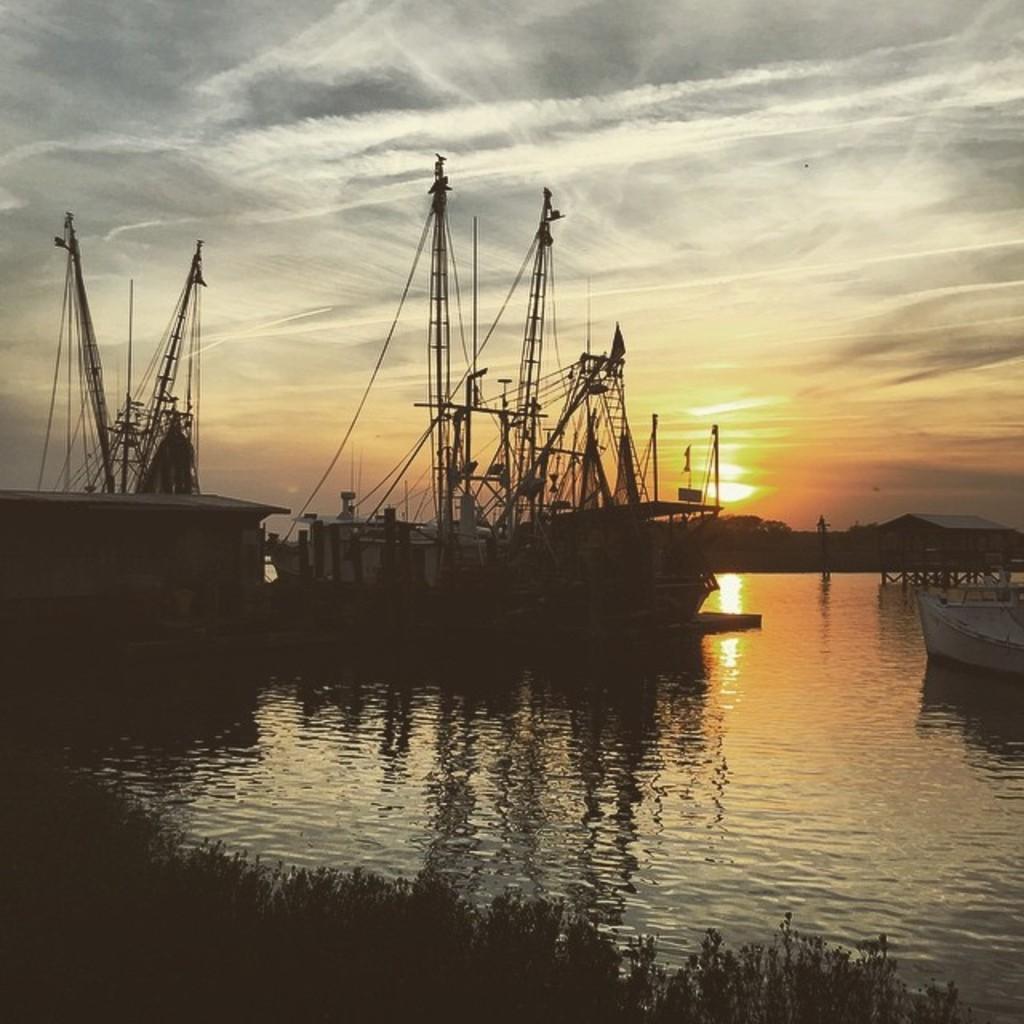Could you give a brief overview of what you see in this image? In this image there is the sky truncated towards the top of the image, there is the sun in the sky, there is a building, there are trees, there is water, there are ships in the water, there is a building truncated towards the left of the image, there are plants truncated towards the bottom of the image, there is an object truncated towards the right of the image. 